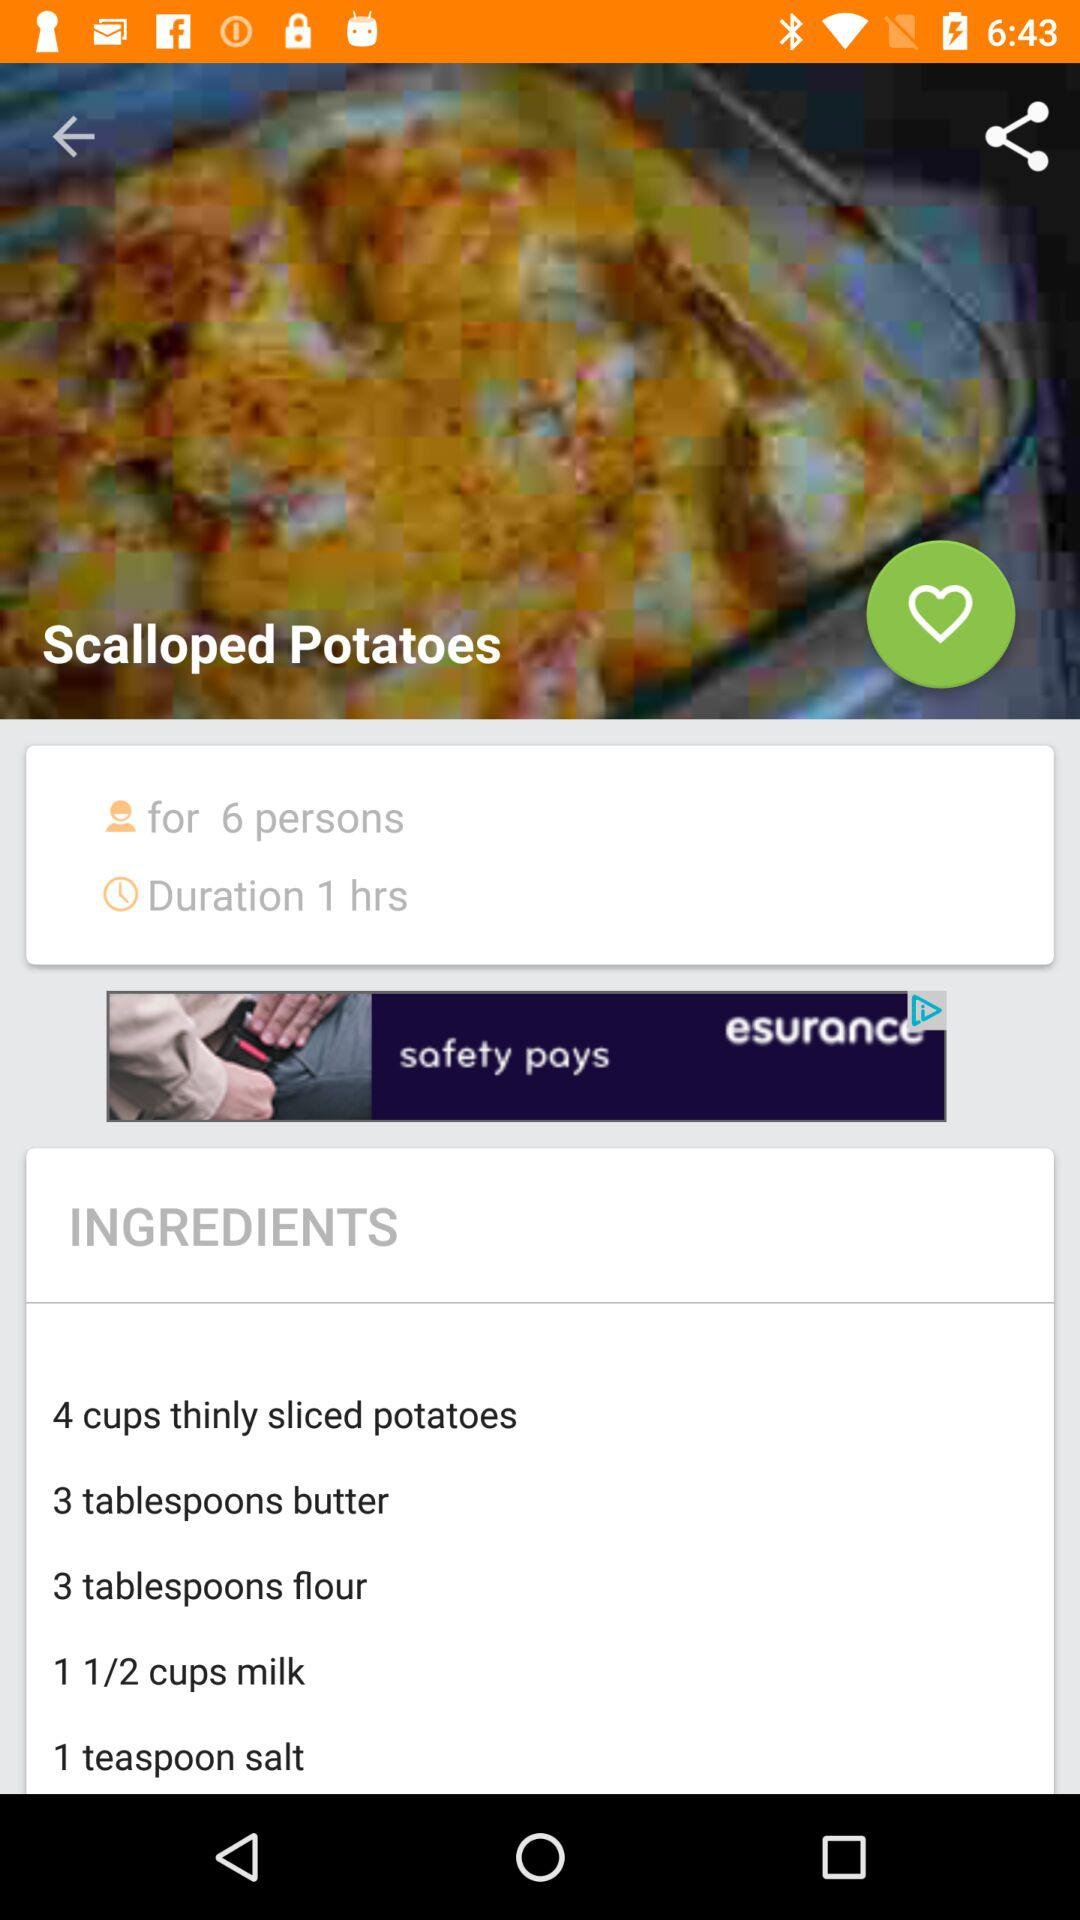What ingredients will be used to make "Scalloped Potatoes"? The ingredients that will be used to make "Scalloped Potatoes" are "4 cups thinly sliced potatoes", "3 tablespoons butter", "3 tablespoons flour", "1 1/2 cups milk" and "1 teaspoon salt". 